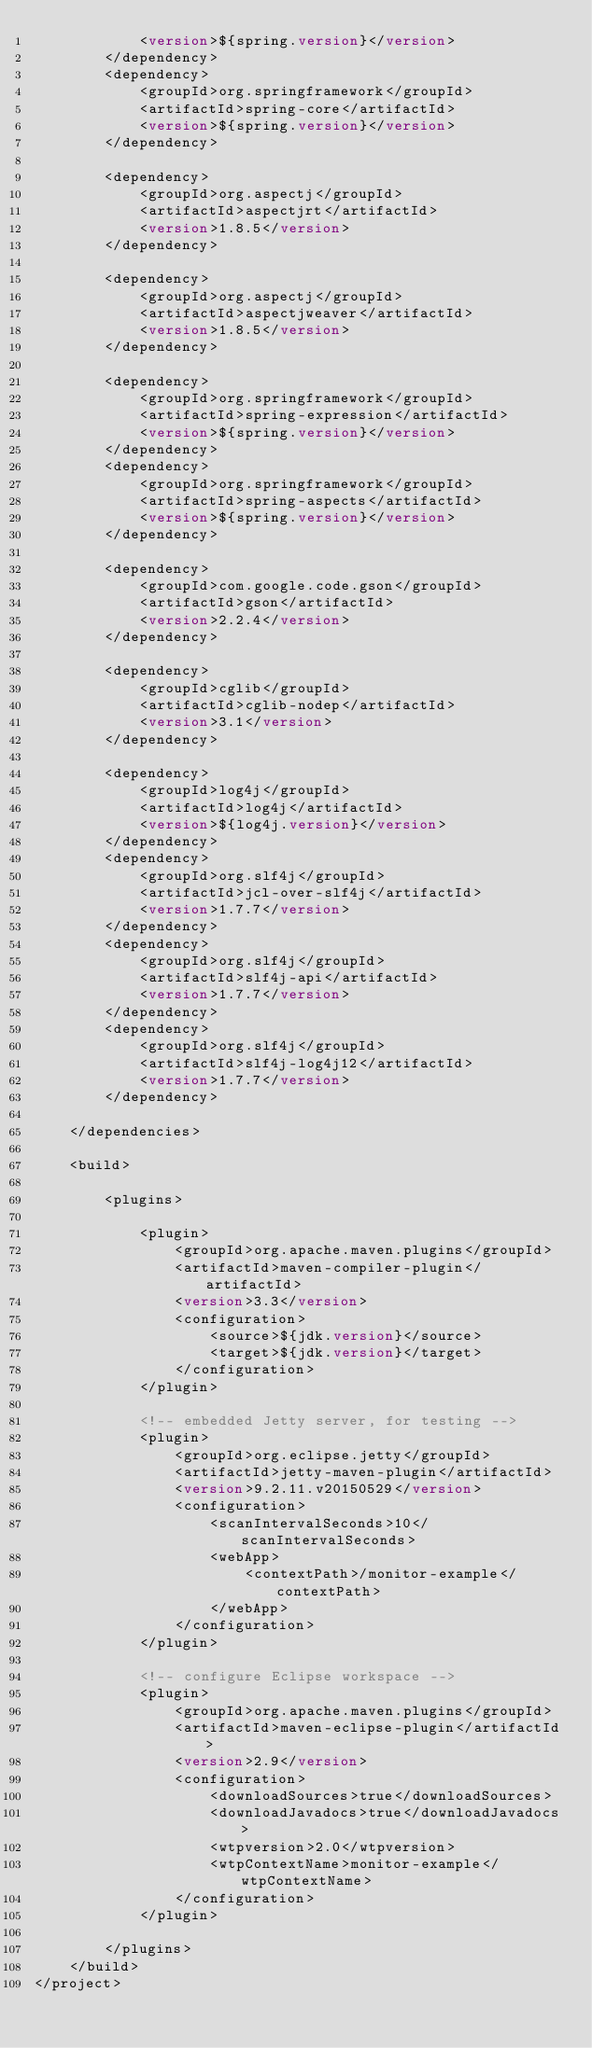Convert code to text. <code><loc_0><loc_0><loc_500><loc_500><_XML_>            <version>${spring.version}</version>
        </dependency>
        <dependency>
            <groupId>org.springframework</groupId>
            <artifactId>spring-core</artifactId>
            <version>${spring.version}</version>
        </dependency>

        <dependency>
            <groupId>org.aspectj</groupId>
            <artifactId>aspectjrt</artifactId>
            <version>1.8.5</version>
        </dependency>

        <dependency>
            <groupId>org.aspectj</groupId>
            <artifactId>aspectjweaver</artifactId>
            <version>1.8.5</version>
        </dependency>

        <dependency>
            <groupId>org.springframework</groupId>
            <artifactId>spring-expression</artifactId>
            <version>${spring.version}</version>
        </dependency>
        <dependency>
            <groupId>org.springframework</groupId>
            <artifactId>spring-aspects</artifactId>
            <version>${spring.version}</version>
        </dependency>

        <dependency>
            <groupId>com.google.code.gson</groupId>
            <artifactId>gson</artifactId>
            <version>2.2.4</version>
        </dependency>

        <dependency>
            <groupId>cglib</groupId>
            <artifactId>cglib-nodep</artifactId>
            <version>3.1</version>
        </dependency>

        <dependency>
            <groupId>log4j</groupId>
            <artifactId>log4j</artifactId>
            <version>${log4j.version}</version>
        </dependency>
        <dependency>
            <groupId>org.slf4j</groupId>
            <artifactId>jcl-over-slf4j</artifactId>
            <version>1.7.7</version>
        </dependency>
        <dependency>
            <groupId>org.slf4j</groupId>
            <artifactId>slf4j-api</artifactId>
            <version>1.7.7</version>
        </dependency>
        <dependency>
            <groupId>org.slf4j</groupId>
            <artifactId>slf4j-log4j12</artifactId>
            <version>1.7.7</version>
        </dependency>

    </dependencies>

    <build>

        <plugins>

            <plugin>
                <groupId>org.apache.maven.plugins</groupId>
                <artifactId>maven-compiler-plugin</artifactId>
                <version>3.3</version>
                <configuration>
                    <source>${jdk.version}</source>
                    <target>${jdk.version}</target>
                </configuration>
            </plugin>

            <!-- embedded Jetty server, for testing -->
            <plugin>
                <groupId>org.eclipse.jetty</groupId>
                <artifactId>jetty-maven-plugin</artifactId>
                <version>9.2.11.v20150529</version>
                <configuration>
                    <scanIntervalSeconds>10</scanIntervalSeconds>
                    <webApp>
                        <contextPath>/monitor-example</contextPath>
                    </webApp>
                </configuration>
            </plugin>

            <!-- configure Eclipse workspace -->
            <plugin>
                <groupId>org.apache.maven.plugins</groupId>
                <artifactId>maven-eclipse-plugin</artifactId>
                <version>2.9</version>
                <configuration>
                    <downloadSources>true</downloadSources>
                    <downloadJavadocs>true</downloadJavadocs>
                    <wtpversion>2.0</wtpversion>
                    <wtpContextName>monitor-example</wtpContextName>
                </configuration>
            </plugin>

        </plugins>
    </build>
</project>
</code> 